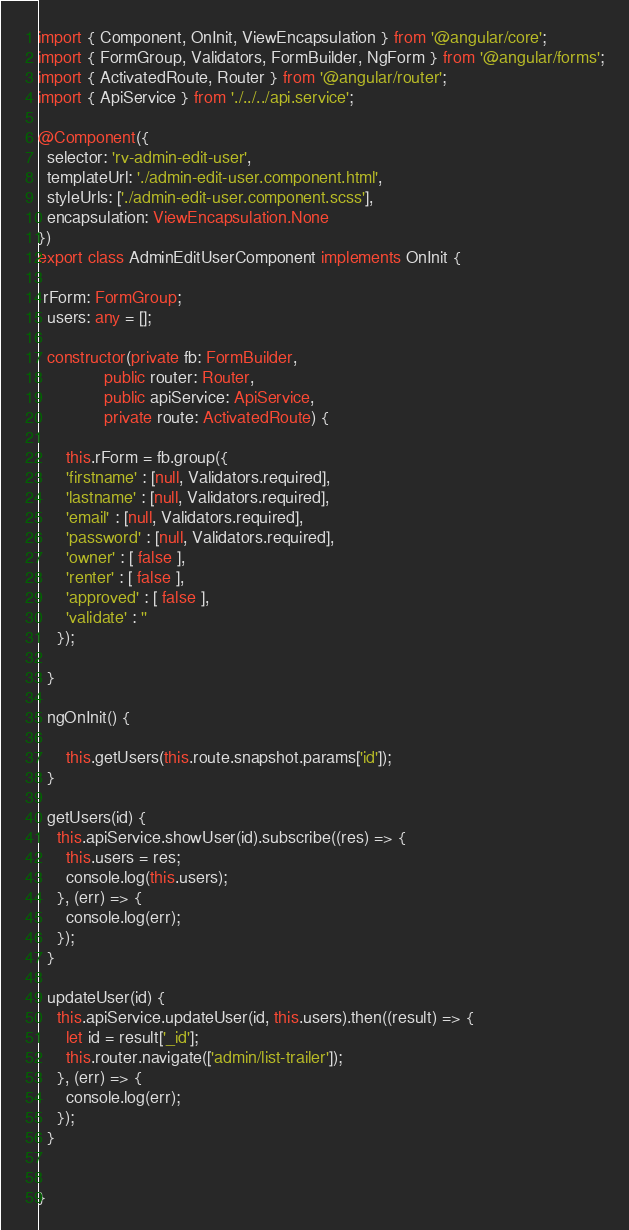<code> <loc_0><loc_0><loc_500><loc_500><_TypeScript_>import { Component, OnInit, ViewEncapsulation } from '@angular/core';
import { FormGroup, Validators, FormBuilder, NgForm } from '@angular/forms';
import { ActivatedRoute, Router } from '@angular/router';
import { ApiService } from './../../api.service';

@Component({
  selector: 'rv-admin-edit-user',
  templateUrl: './admin-edit-user.component.html',
  styleUrls: ['./admin-edit-user.component.scss'],
  encapsulation: ViewEncapsulation.None
})
export class AdminEditUserComponent implements OnInit {

 rForm: FormGroup;
  users: any = [];

  constructor(private fb: FormBuilder,
              public router: Router,
              public apiService: ApiService,
              private route: ActivatedRoute) {

      this.rForm = fb.group({
      'firstname' : [null, Validators.required],
      'lastname' : [null, Validators.required],
      'email' : [null, Validators.required],
      'password' : [null, Validators.required],
      'owner' : [ false ],
      'renter' : [ false ],
      'approved' : [ false ],
      'validate' : ''
    });

  }

  ngOnInit() {

      this.getUsers(this.route.snapshot.params['id']);
  }

  getUsers(id) {
    this.apiService.showUser(id).subscribe((res) => {
      this.users = res;
      console.log(this.users);
    }, (err) => {
      console.log(err);
    });
  }

  updateUser(id) {
    this.apiService.updateUser(id, this.users).then((result) => {
      let id = result['_id'];
      this.router.navigate(['admin/list-trailer']);
    }, (err) => {
      console.log(err);
    });
  }


}
</code> 